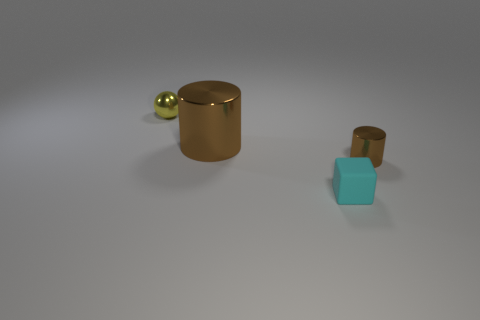There is a brown shiny cylinder that is behind the cylinder that is in front of the large cylinder left of the tiny brown metallic cylinder; how big is it?
Provide a succinct answer. Large. How many other objects are there of the same shape as the small cyan object?
Your response must be concise. 0. What color is the object that is in front of the large metal cylinder and behind the small cyan rubber thing?
Offer a very short reply. Brown. Is there any other thing that has the same size as the yellow object?
Give a very brief answer. Yes. Is the color of the tiny metal thing that is left of the tiny cyan cube the same as the big object?
Your answer should be very brief. No. What number of blocks are rubber objects or big brown things?
Make the answer very short. 1. What is the shape of the small shiny object that is to the right of the yellow ball?
Offer a terse response. Cylinder. There is a shiny object to the left of the brown shiny object left of the brown cylinder that is on the right side of the cyan rubber cube; what is its color?
Keep it short and to the point. Yellow. Do the yellow thing and the big brown thing have the same material?
Offer a very short reply. Yes. What number of blue objects are either tiny metallic balls or metal things?
Offer a terse response. 0. 